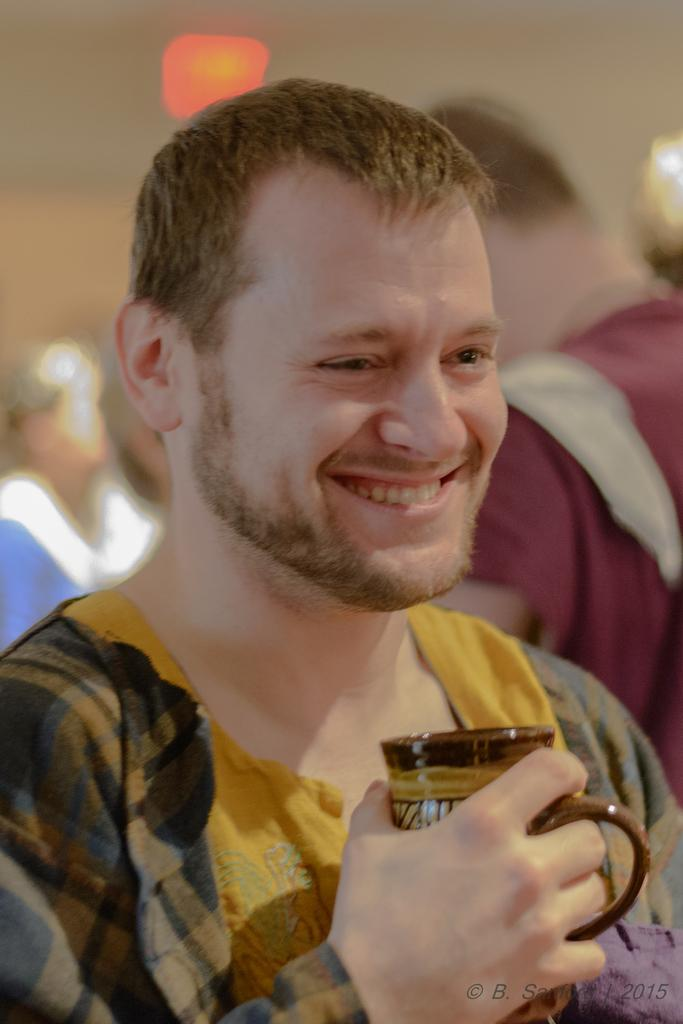Who is the main subject in the image? There is a man in the center of the image. What is the man holding in the image? The man is holding a cup. Can you describe the surroundings of the man in the image? There are people in the background of the image. What type of feeling does the man have towards the suggestion in the image? There is no suggestion present in the image, so it is not possible to determine the man's feelings towards it. 